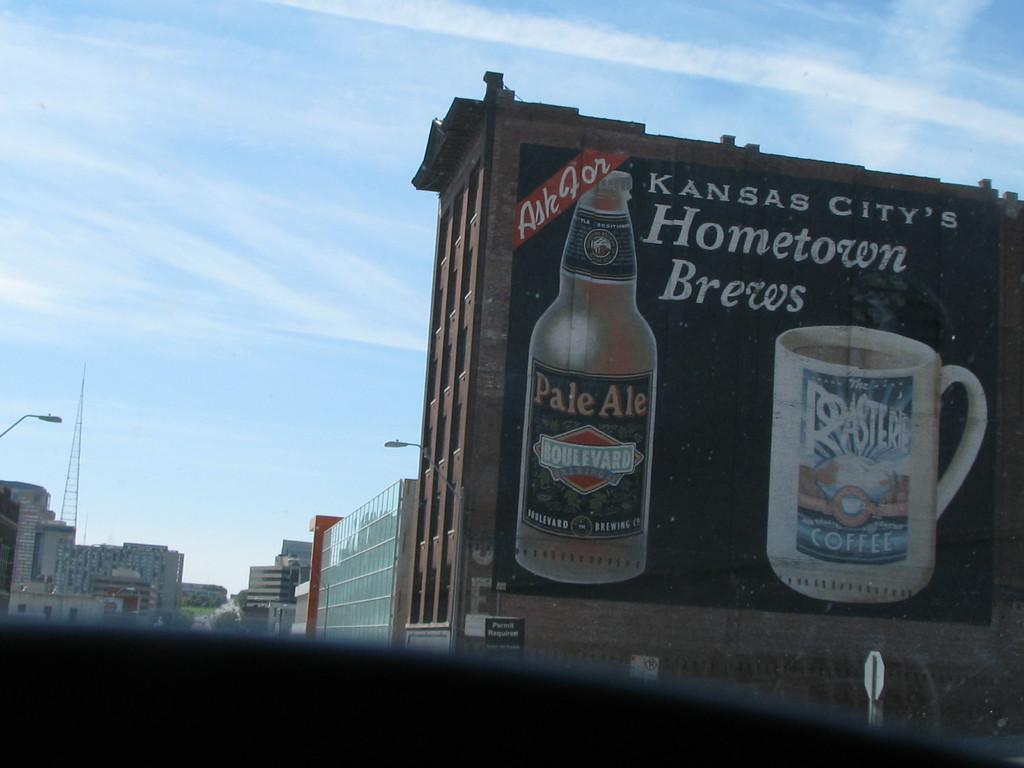Provide a one-sentence caption for the provided image. A mural on the side of a brick building advertises Kansas City's Hometown brews. 